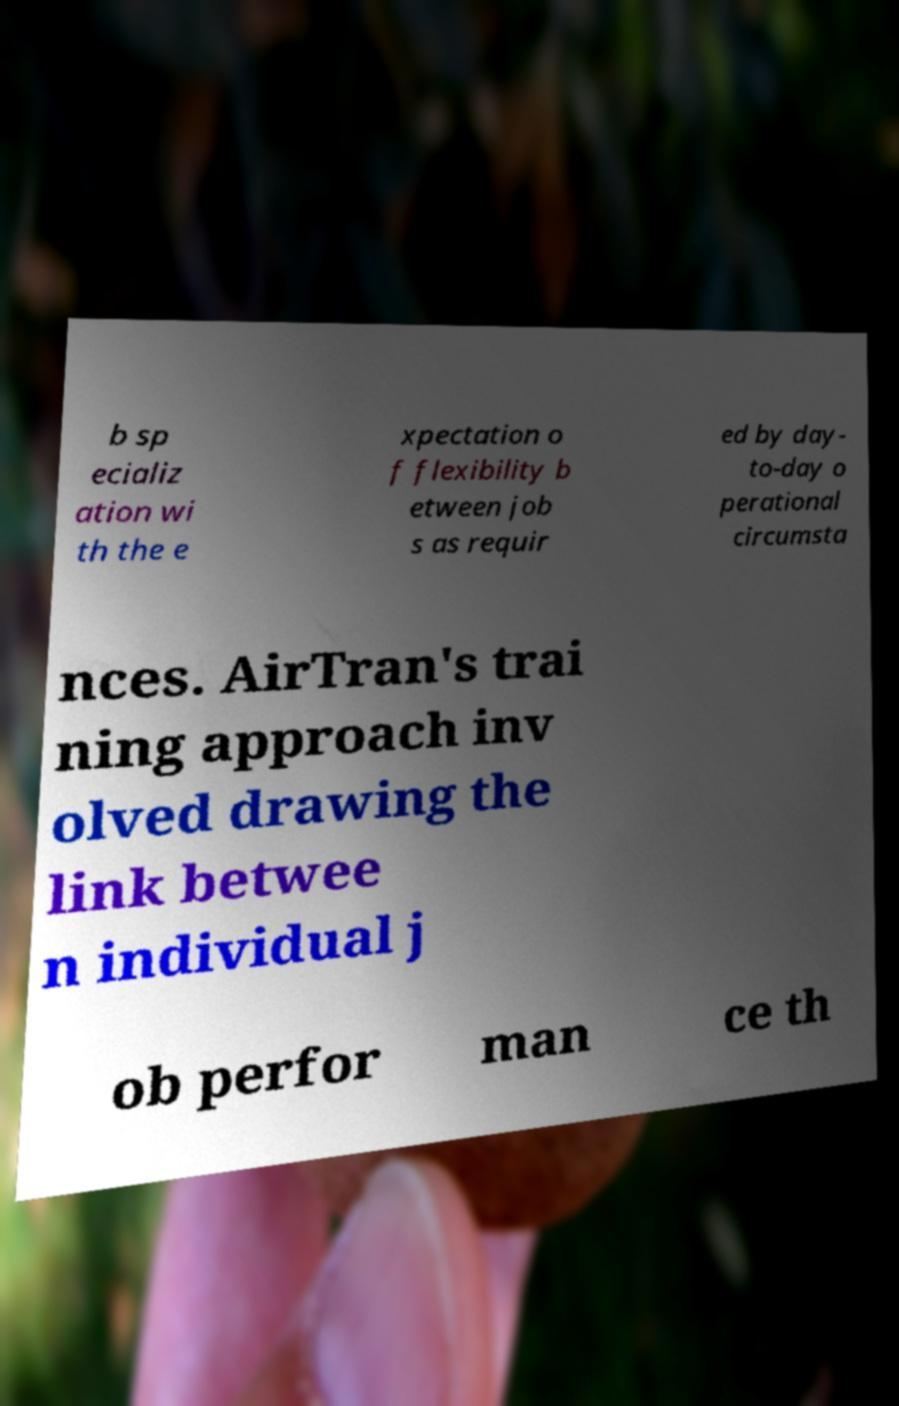Please read and relay the text visible in this image. What does it say? b sp ecializ ation wi th the e xpectation o f flexibility b etween job s as requir ed by day- to-day o perational circumsta nces. AirTran's trai ning approach inv olved drawing the link betwee n individual j ob perfor man ce th 